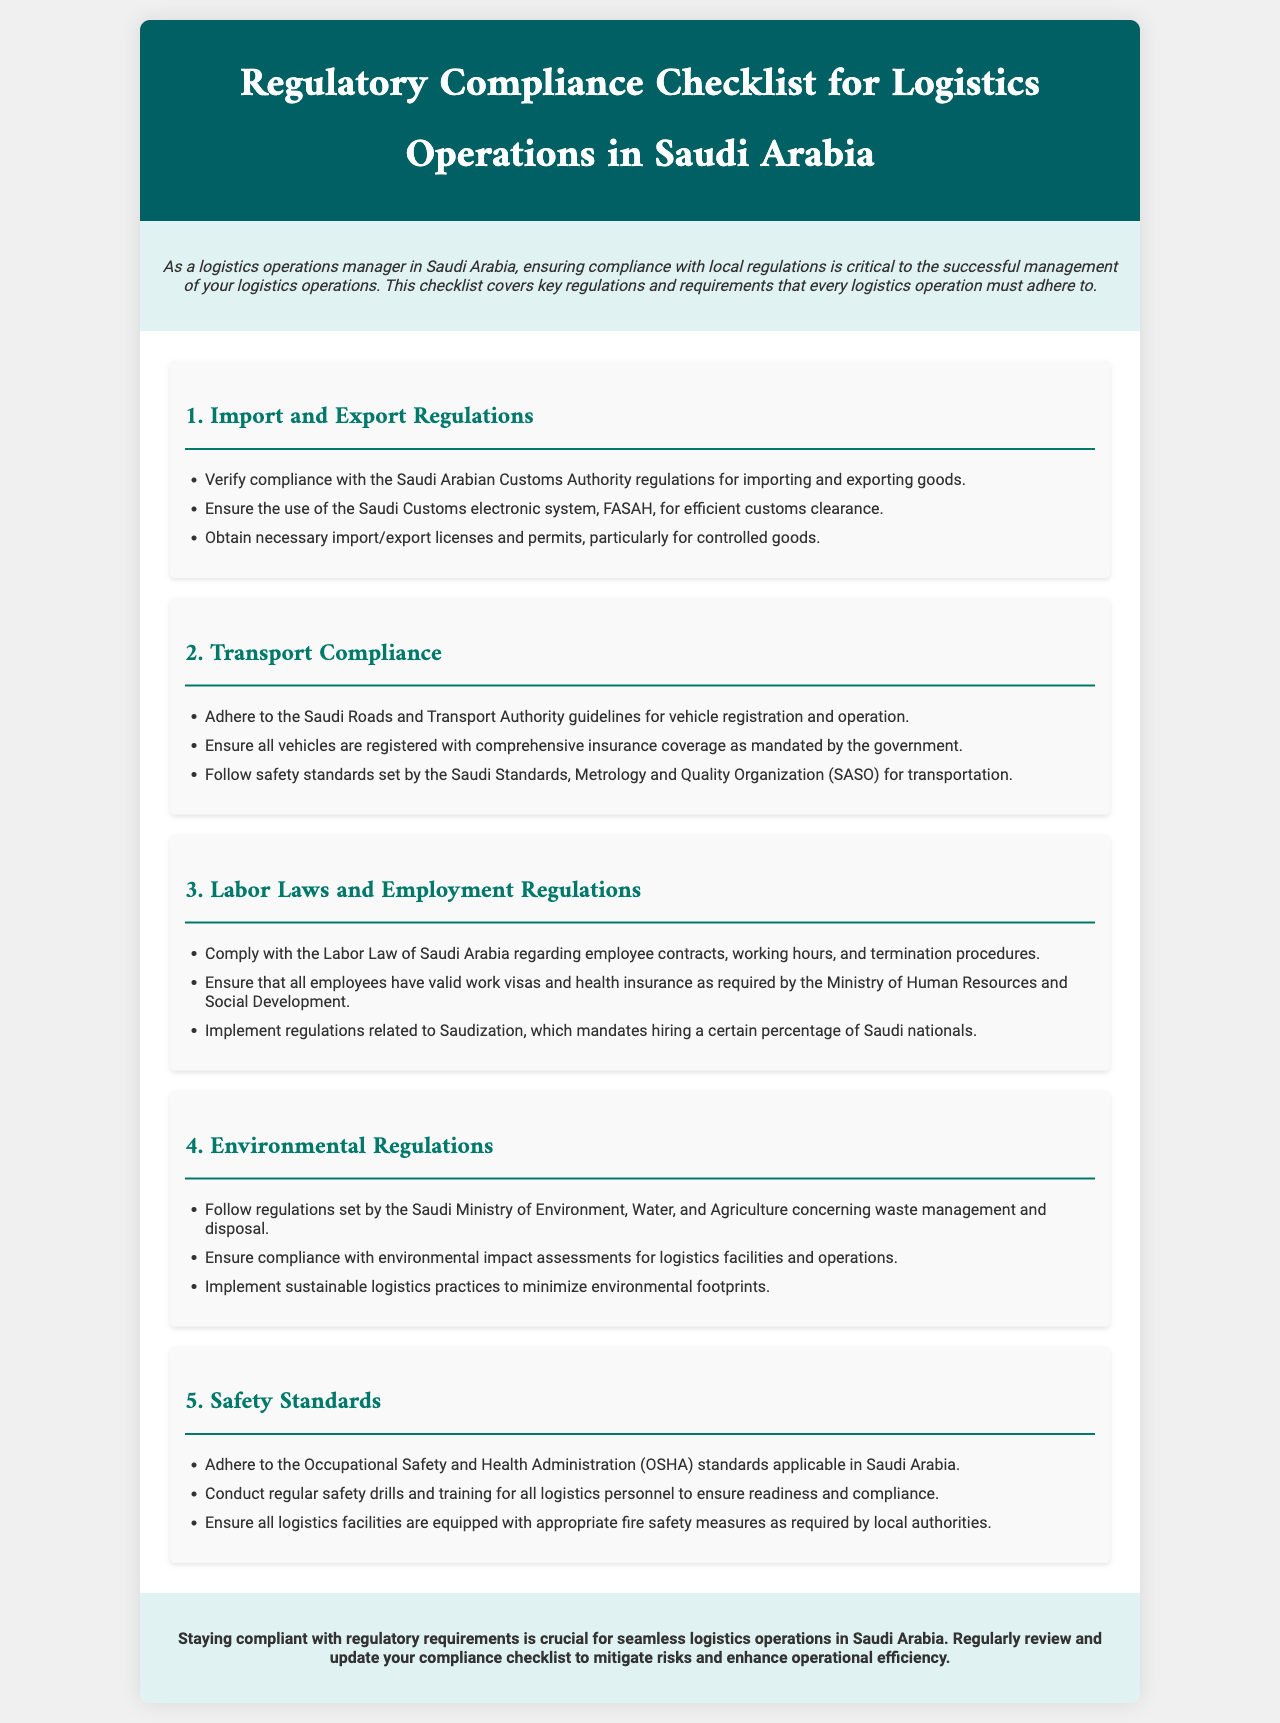what are the three key sections in the checklist? The key sections include Import and Export Regulations, Transport Compliance, and Labor Laws and Employment Regulations.
Answer: Import and Export Regulations, Transport Compliance, Labor Laws and Employment Regulations who regulates environmental practices in Saudi Arabia? The regulatory body for environmental practices is mentioned in the brochure.
Answer: Saudi Ministry of Environment, Water, and Agriculture how many main sections are there in the checklist? The brochure explicitly outlines the total number of sections within the checklist.
Answer: Five what electronic system is used for customs clearance? The document specifies a particular electronic system that must be used for customs clearance.
Answer: FASAH which organization sets safety standards for transportation? The document identifies an organization associated with transportation safety standards.
Answer: Saudi Standards, Metrology and Quality Organization (SASO) what is one requirement under the Labor Laws of Saudi Arabia? The brochure states specific obligations related to employee contracts under labor laws.
Answer: Employee contracts what must all vehicles in logistics operations have? The section discussing transport compliance mentions a necessary requirement for vehicles.
Answer: Comprehensive insurance coverage what type of regulations must be followed for waste management? This is addressed under the environmental regulations section in the brochure.
Answer: Regulations set by the Saudi Ministry of Environment, Water, and Agriculture what is the purpose of the compliance checklist? The introductory section of the document outlines the overall purpose of the checklist.
Answer: Ensure compliance with local regulations 